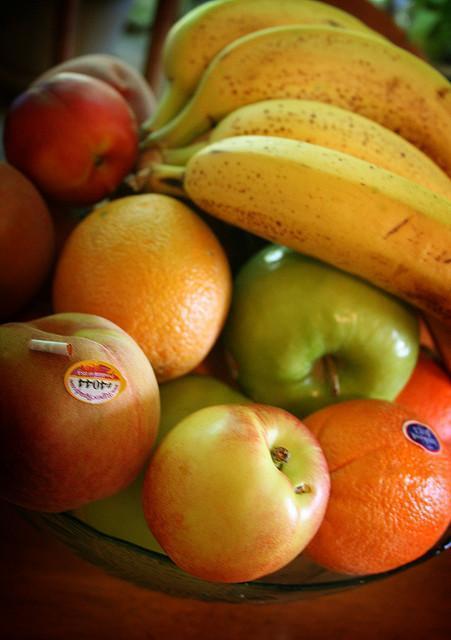How many pieces of fruit has stickers on them?
Give a very brief answer. 2. How many bowls are there?
Give a very brief answer. 2. How many apples are visible?
Give a very brief answer. 6. How many oranges are in the picture?
Give a very brief answer. 4. 